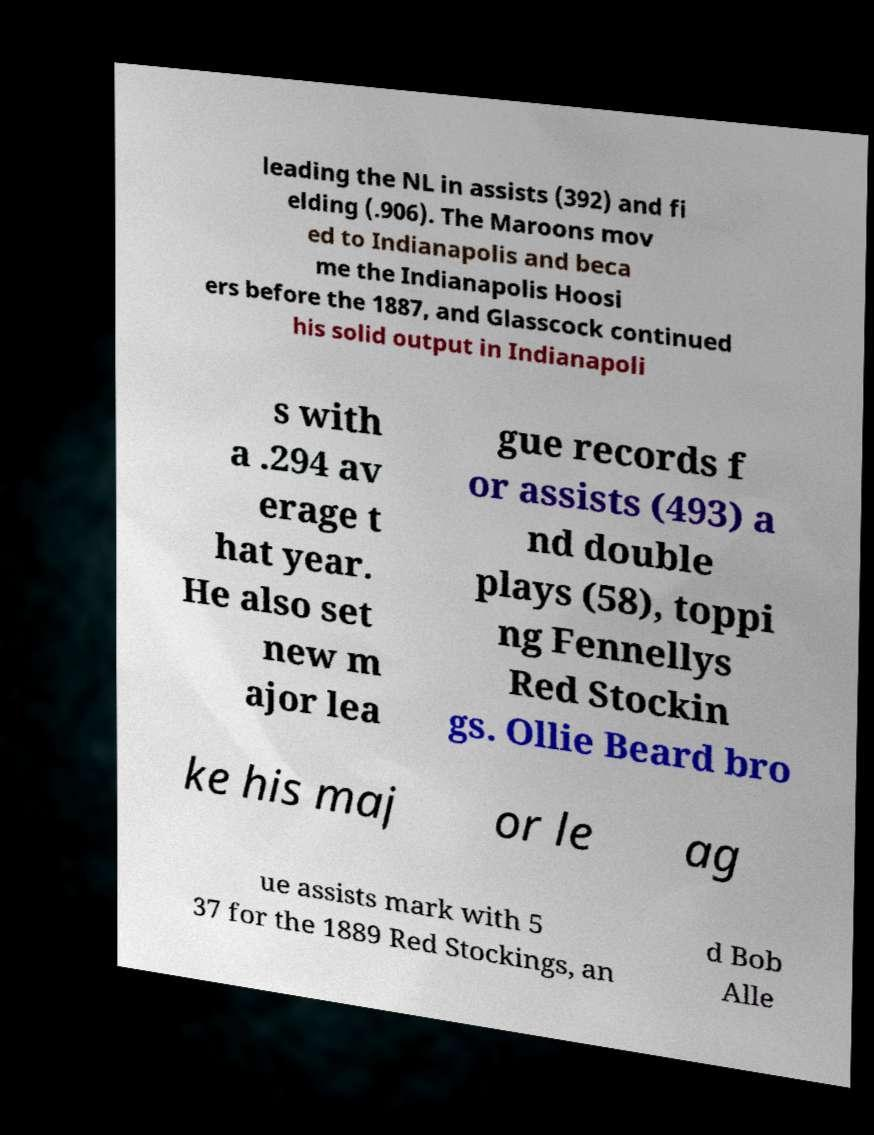Please read and relay the text visible in this image. What does it say? leading the NL in assists (392) and fi elding (.906). The Maroons mov ed to Indianapolis and beca me the Indianapolis Hoosi ers before the 1887, and Glasscock continued his solid output in Indianapoli s with a .294 av erage t hat year. He also set new m ajor lea gue records f or assists (493) a nd double plays (58), toppi ng Fennellys Red Stockin gs. Ollie Beard bro ke his maj or le ag ue assists mark with 5 37 for the 1889 Red Stockings, an d Bob Alle 